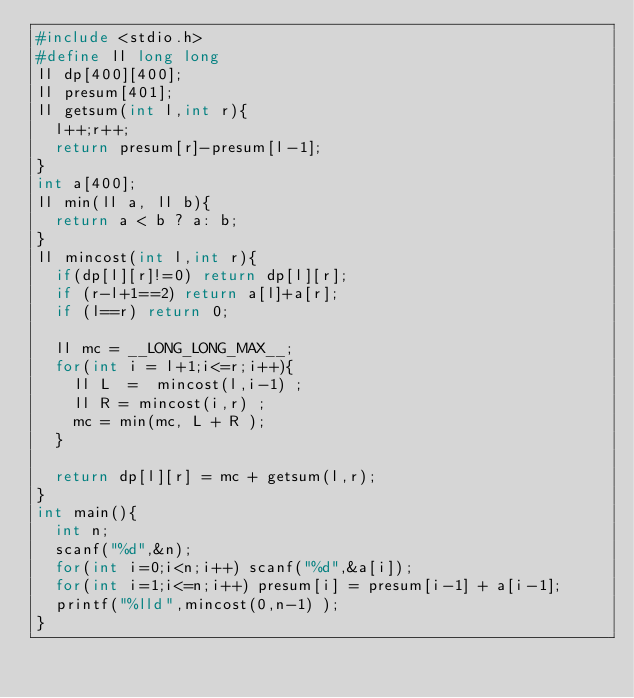Convert code to text. <code><loc_0><loc_0><loc_500><loc_500><_C_>#include <stdio.h>
#define ll long long
ll dp[400][400];
ll presum[401];
ll getsum(int l,int r){
	l++;r++;
	return presum[r]-presum[l-1];
}
int a[400];
ll min(ll a, ll b){
	return a < b ? a: b;
}
ll mincost(int l,int r){
	if(dp[l][r]!=0) return dp[l][r];
	if (r-l+1==2) return a[l]+a[r];
	if (l==r) return 0;
	
	ll mc = __LONG_LONG_MAX__;
	for(int i = l+1;i<=r;i++){
		ll L  =  mincost(l,i-1) ;
		ll R = mincost(i,r) ;
		mc = min(mc, L + R );
	}

	return dp[l][r] = mc + getsum(l,r);
}
int main(){
	int n;
	scanf("%d",&n);
	for(int i=0;i<n;i++) scanf("%d",&a[i]);
	for(int i=1;i<=n;i++) presum[i] = presum[i-1] + a[i-1];
	printf("%lld",mincost(0,n-1) );
}</code> 